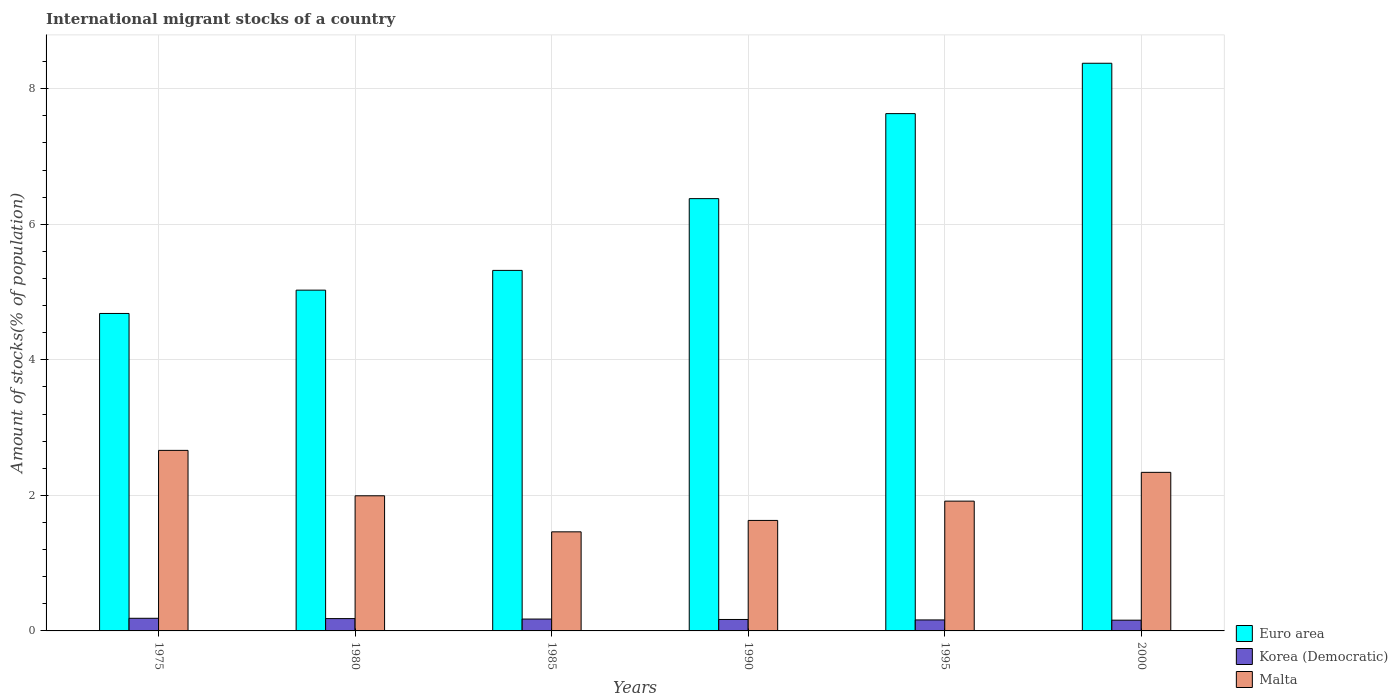How many different coloured bars are there?
Provide a short and direct response. 3. How many groups of bars are there?
Your response must be concise. 6. How many bars are there on the 5th tick from the left?
Keep it short and to the point. 3. What is the label of the 2nd group of bars from the left?
Make the answer very short. 1980. What is the amount of stocks in in Korea (Democratic) in 2000?
Offer a terse response. 0.16. Across all years, what is the maximum amount of stocks in in Euro area?
Your answer should be compact. 8.38. Across all years, what is the minimum amount of stocks in in Euro area?
Provide a short and direct response. 4.68. In which year was the amount of stocks in in Euro area minimum?
Ensure brevity in your answer.  1975. What is the total amount of stocks in in Korea (Democratic) in the graph?
Make the answer very short. 1.03. What is the difference between the amount of stocks in in Korea (Democratic) in 1975 and that in 1995?
Give a very brief answer. 0.02. What is the difference between the amount of stocks in in Korea (Democratic) in 1995 and the amount of stocks in in Malta in 1990?
Make the answer very short. -1.47. What is the average amount of stocks in in Malta per year?
Your answer should be compact. 2. In the year 1980, what is the difference between the amount of stocks in in Malta and amount of stocks in in Korea (Democratic)?
Your answer should be compact. 1.81. In how many years, is the amount of stocks in in Malta greater than 4.8 %?
Your response must be concise. 0. What is the ratio of the amount of stocks in in Malta in 1975 to that in 1980?
Ensure brevity in your answer.  1.34. What is the difference between the highest and the second highest amount of stocks in in Euro area?
Your answer should be compact. 0.74. What is the difference between the highest and the lowest amount of stocks in in Korea (Democratic)?
Provide a succinct answer. 0.03. In how many years, is the amount of stocks in in Malta greater than the average amount of stocks in in Malta taken over all years?
Offer a terse response. 2. What does the 3rd bar from the left in 1995 represents?
Provide a short and direct response. Malta. What does the 1st bar from the right in 1985 represents?
Offer a terse response. Malta. Does the graph contain any zero values?
Give a very brief answer. No. Does the graph contain grids?
Your response must be concise. Yes. Where does the legend appear in the graph?
Keep it short and to the point. Bottom right. How are the legend labels stacked?
Offer a very short reply. Vertical. What is the title of the graph?
Make the answer very short. International migrant stocks of a country. Does "Philippines" appear as one of the legend labels in the graph?
Offer a terse response. No. What is the label or title of the Y-axis?
Offer a very short reply. Amount of stocks(% of population). What is the Amount of stocks(% of population) in Euro area in 1975?
Offer a very short reply. 4.68. What is the Amount of stocks(% of population) in Korea (Democratic) in 1975?
Your answer should be compact. 0.19. What is the Amount of stocks(% of population) of Malta in 1975?
Your answer should be very brief. 2.66. What is the Amount of stocks(% of population) in Euro area in 1980?
Offer a terse response. 5.03. What is the Amount of stocks(% of population) in Korea (Democratic) in 1980?
Make the answer very short. 0.18. What is the Amount of stocks(% of population) in Malta in 1980?
Provide a short and direct response. 1.99. What is the Amount of stocks(% of population) in Euro area in 1985?
Provide a short and direct response. 5.32. What is the Amount of stocks(% of population) in Korea (Democratic) in 1985?
Give a very brief answer. 0.17. What is the Amount of stocks(% of population) of Malta in 1985?
Your response must be concise. 1.46. What is the Amount of stocks(% of population) in Euro area in 1990?
Your answer should be compact. 6.38. What is the Amount of stocks(% of population) of Korea (Democratic) in 1990?
Offer a terse response. 0.17. What is the Amount of stocks(% of population) in Malta in 1990?
Give a very brief answer. 1.63. What is the Amount of stocks(% of population) of Euro area in 1995?
Your answer should be compact. 7.63. What is the Amount of stocks(% of population) in Korea (Democratic) in 1995?
Make the answer very short. 0.16. What is the Amount of stocks(% of population) in Malta in 1995?
Offer a very short reply. 1.92. What is the Amount of stocks(% of population) in Euro area in 2000?
Offer a very short reply. 8.38. What is the Amount of stocks(% of population) of Korea (Democratic) in 2000?
Your response must be concise. 0.16. What is the Amount of stocks(% of population) in Malta in 2000?
Provide a short and direct response. 2.34. Across all years, what is the maximum Amount of stocks(% of population) in Euro area?
Offer a terse response. 8.38. Across all years, what is the maximum Amount of stocks(% of population) of Korea (Democratic)?
Your response must be concise. 0.19. Across all years, what is the maximum Amount of stocks(% of population) in Malta?
Make the answer very short. 2.66. Across all years, what is the minimum Amount of stocks(% of population) in Euro area?
Your response must be concise. 4.68. Across all years, what is the minimum Amount of stocks(% of population) in Korea (Democratic)?
Provide a short and direct response. 0.16. Across all years, what is the minimum Amount of stocks(% of population) in Malta?
Your answer should be compact. 1.46. What is the total Amount of stocks(% of population) in Euro area in the graph?
Your response must be concise. 37.42. What is the total Amount of stocks(% of population) of Korea (Democratic) in the graph?
Give a very brief answer. 1.03. What is the total Amount of stocks(% of population) of Malta in the graph?
Ensure brevity in your answer.  12. What is the difference between the Amount of stocks(% of population) in Euro area in 1975 and that in 1980?
Your answer should be very brief. -0.34. What is the difference between the Amount of stocks(% of population) of Korea (Democratic) in 1975 and that in 1980?
Offer a terse response. 0. What is the difference between the Amount of stocks(% of population) in Malta in 1975 and that in 1980?
Ensure brevity in your answer.  0.67. What is the difference between the Amount of stocks(% of population) of Euro area in 1975 and that in 1985?
Make the answer very short. -0.64. What is the difference between the Amount of stocks(% of population) of Korea (Democratic) in 1975 and that in 1985?
Keep it short and to the point. 0.01. What is the difference between the Amount of stocks(% of population) of Malta in 1975 and that in 1985?
Provide a succinct answer. 1.2. What is the difference between the Amount of stocks(% of population) in Euro area in 1975 and that in 1990?
Provide a short and direct response. -1.69. What is the difference between the Amount of stocks(% of population) of Korea (Democratic) in 1975 and that in 1990?
Make the answer very short. 0.02. What is the difference between the Amount of stocks(% of population) of Malta in 1975 and that in 1990?
Offer a terse response. 1.03. What is the difference between the Amount of stocks(% of population) in Euro area in 1975 and that in 1995?
Give a very brief answer. -2.95. What is the difference between the Amount of stocks(% of population) of Korea (Democratic) in 1975 and that in 1995?
Ensure brevity in your answer.  0.02. What is the difference between the Amount of stocks(% of population) in Malta in 1975 and that in 1995?
Your answer should be compact. 0.75. What is the difference between the Amount of stocks(% of population) in Euro area in 1975 and that in 2000?
Provide a short and direct response. -3.69. What is the difference between the Amount of stocks(% of population) of Korea (Democratic) in 1975 and that in 2000?
Your answer should be compact. 0.03. What is the difference between the Amount of stocks(% of population) in Malta in 1975 and that in 2000?
Your response must be concise. 0.32. What is the difference between the Amount of stocks(% of population) of Euro area in 1980 and that in 1985?
Your response must be concise. -0.29. What is the difference between the Amount of stocks(% of population) in Korea (Democratic) in 1980 and that in 1985?
Offer a terse response. 0.01. What is the difference between the Amount of stocks(% of population) of Malta in 1980 and that in 1985?
Your answer should be compact. 0.53. What is the difference between the Amount of stocks(% of population) of Euro area in 1980 and that in 1990?
Provide a succinct answer. -1.35. What is the difference between the Amount of stocks(% of population) in Korea (Democratic) in 1980 and that in 1990?
Your answer should be compact. 0.01. What is the difference between the Amount of stocks(% of population) of Malta in 1980 and that in 1990?
Your response must be concise. 0.36. What is the difference between the Amount of stocks(% of population) in Euro area in 1980 and that in 1995?
Offer a terse response. -2.6. What is the difference between the Amount of stocks(% of population) of Korea (Democratic) in 1980 and that in 1995?
Make the answer very short. 0.02. What is the difference between the Amount of stocks(% of population) of Malta in 1980 and that in 1995?
Offer a very short reply. 0.08. What is the difference between the Amount of stocks(% of population) of Euro area in 1980 and that in 2000?
Provide a short and direct response. -3.35. What is the difference between the Amount of stocks(% of population) in Korea (Democratic) in 1980 and that in 2000?
Your answer should be very brief. 0.02. What is the difference between the Amount of stocks(% of population) of Malta in 1980 and that in 2000?
Keep it short and to the point. -0.35. What is the difference between the Amount of stocks(% of population) in Euro area in 1985 and that in 1990?
Your answer should be compact. -1.06. What is the difference between the Amount of stocks(% of population) in Korea (Democratic) in 1985 and that in 1990?
Offer a very short reply. 0.01. What is the difference between the Amount of stocks(% of population) in Malta in 1985 and that in 1990?
Your answer should be compact. -0.17. What is the difference between the Amount of stocks(% of population) of Euro area in 1985 and that in 1995?
Offer a terse response. -2.31. What is the difference between the Amount of stocks(% of population) of Korea (Democratic) in 1985 and that in 1995?
Make the answer very short. 0.01. What is the difference between the Amount of stocks(% of population) in Malta in 1985 and that in 1995?
Your answer should be compact. -0.45. What is the difference between the Amount of stocks(% of population) of Euro area in 1985 and that in 2000?
Provide a succinct answer. -3.06. What is the difference between the Amount of stocks(% of population) of Korea (Democratic) in 1985 and that in 2000?
Provide a succinct answer. 0.02. What is the difference between the Amount of stocks(% of population) in Malta in 1985 and that in 2000?
Provide a short and direct response. -0.88. What is the difference between the Amount of stocks(% of population) in Euro area in 1990 and that in 1995?
Provide a succinct answer. -1.25. What is the difference between the Amount of stocks(% of population) of Korea (Democratic) in 1990 and that in 1995?
Keep it short and to the point. 0.01. What is the difference between the Amount of stocks(% of population) of Malta in 1990 and that in 1995?
Provide a short and direct response. -0.28. What is the difference between the Amount of stocks(% of population) of Euro area in 1990 and that in 2000?
Provide a short and direct response. -2. What is the difference between the Amount of stocks(% of population) in Korea (Democratic) in 1990 and that in 2000?
Ensure brevity in your answer.  0.01. What is the difference between the Amount of stocks(% of population) of Malta in 1990 and that in 2000?
Ensure brevity in your answer.  -0.71. What is the difference between the Amount of stocks(% of population) in Euro area in 1995 and that in 2000?
Provide a short and direct response. -0.74. What is the difference between the Amount of stocks(% of population) in Korea (Democratic) in 1995 and that in 2000?
Ensure brevity in your answer.  0. What is the difference between the Amount of stocks(% of population) in Malta in 1995 and that in 2000?
Provide a short and direct response. -0.42. What is the difference between the Amount of stocks(% of population) in Euro area in 1975 and the Amount of stocks(% of population) in Korea (Democratic) in 1980?
Keep it short and to the point. 4.5. What is the difference between the Amount of stocks(% of population) in Euro area in 1975 and the Amount of stocks(% of population) in Malta in 1980?
Keep it short and to the point. 2.69. What is the difference between the Amount of stocks(% of population) in Korea (Democratic) in 1975 and the Amount of stocks(% of population) in Malta in 1980?
Offer a very short reply. -1.81. What is the difference between the Amount of stocks(% of population) in Euro area in 1975 and the Amount of stocks(% of population) in Korea (Democratic) in 1985?
Your response must be concise. 4.51. What is the difference between the Amount of stocks(% of population) of Euro area in 1975 and the Amount of stocks(% of population) of Malta in 1985?
Make the answer very short. 3.22. What is the difference between the Amount of stocks(% of population) in Korea (Democratic) in 1975 and the Amount of stocks(% of population) in Malta in 1985?
Keep it short and to the point. -1.28. What is the difference between the Amount of stocks(% of population) in Euro area in 1975 and the Amount of stocks(% of population) in Korea (Democratic) in 1990?
Keep it short and to the point. 4.52. What is the difference between the Amount of stocks(% of population) of Euro area in 1975 and the Amount of stocks(% of population) of Malta in 1990?
Provide a succinct answer. 3.05. What is the difference between the Amount of stocks(% of population) in Korea (Democratic) in 1975 and the Amount of stocks(% of population) in Malta in 1990?
Offer a very short reply. -1.44. What is the difference between the Amount of stocks(% of population) of Euro area in 1975 and the Amount of stocks(% of population) of Korea (Democratic) in 1995?
Offer a very short reply. 4.52. What is the difference between the Amount of stocks(% of population) in Euro area in 1975 and the Amount of stocks(% of population) in Malta in 1995?
Your response must be concise. 2.77. What is the difference between the Amount of stocks(% of population) of Korea (Democratic) in 1975 and the Amount of stocks(% of population) of Malta in 1995?
Offer a very short reply. -1.73. What is the difference between the Amount of stocks(% of population) in Euro area in 1975 and the Amount of stocks(% of population) in Korea (Democratic) in 2000?
Offer a very short reply. 4.53. What is the difference between the Amount of stocks(% of population) in Euro area in 1975 and the Amount of stocks(% of population) in Malta in 2000?
Your answer should be compact. 2.34. What is the difference between the Amount of stocks(% of population) of Korea (Democratic) in 1975 and the Amount of stocks(% of population) of Malta in 2000?
Your answer should be very brief. -2.15. What is the difference between the Amount of stocks(% of population) of Euro area in 1980 and the Amount of stocks(% of population) of Korea (Democratic) in 1985?
Keep it short and to the point. 4.85. What is the difference between the Amount of stocks(% of population) in Euro area in 1980 and the Amount of stocks(% of population) in Malta in 1985?
Offer a very short reply. 3.57. What is the difference between the Amount of stocks(% of population) of Korea (Democratic) in 1980 and the Amount of stocks(% of population) of Malta in 1985?
Your answer should be compact. -1.28. What is the difference between the Amount of stocks(% of population) of Euro area in 1980 and the Amount of stocks(% of population) of Korea (Democratic) in 1990?
Your answer should be compact. 4.86. What is the difference between the Amount of stocks(% of population) in Euro area in 1980 and the Amount of stocks(% of population) in Malta in 1990?
Your answer should be very brief. 3.4. What is the difference between the Amount of stocks(% of population) in Korea (Democratic) in 1980 and the Amount of stocks(% of population) in Malta in 1990?
Offer a terse response. -1.45. What is the difference between the Amount of stocks(% of population) of Euro area in 1980 and the Amount of stocks(% of population) of Korea (Democratic) in 1995?
Make the answer very short. 4.87. What is the difference between the Amount of stocks(% of population) of Euro area in 1980 and the Amount of stocks(% of population) of Malta in 1995?
Ensure brevity in your answer.  3.11. What is the difference between the Amount of stocks(% of population) in Korea (Democratic) in 1980 and the Amount of stocks(% of population) in Malta in 1995?
Keep it short and to the point. -1.73. What is the difference between the Amount of stocks(% of population) in Euro area in 1980 and the Amount of stocks(% of population) in Korea (Democratic) in 2000?
Give a very brief answer. 4.87. What is the difference between the Amount of stocks(% of population) of Euro area in 1980 and the Amount of stocks(% of population) of Malta in 2000?
Keep it short and to the point. 2.69. What is the difference between the Amount of stocks(% of population) in Korea (Democratic) in 1980 and the Amount of stocks(% of population) in Malta in 2000?
Your answer should be compact. -2.16. What is the difference between the Amount of stocks(% of population) of Euro area in 1985 and the Amount of stocks(% of population) of Korea (Democratic) in 1990?
Offer a very short reply. 5.15. What is the difference between the Amount of stocks(% of population) of Euro area in 1985 and the Amount of stocks(% of population) of Malta in 1990?
Offer a very short reply. 3.69. What is the difference between the Amount of stocks(% of population) in Korea (Democratic) in 1985 and the Amount of stocks(% of population) in Malta in 1990?
Offer a very short reply. -1.46. What is the difference between the Amount of stocks(% of population) of Euro area in 1985 and the Amount of stocks(% of population) of Korea (Democratic) in 1995?
Give a very brief answer. 5.16. What is the difference between the Amount of stocks(% of population) of Euro area in 1985 and the Amount of stocks(% of population) of Malta in 1995?
Offer a very short reply. 3.4. What is the difference between the Amount of stocks(% of population) in Korea (Democratic) in 1985 and the Amount of stocks(% of population) in Malta in 1995?
Make the answer very short. -1.74. What is the difference between the Amount of stocks(% of population) in Euro area in 1985 and the Amount of stocks(% of population) in Korea (Democratic) in 2000?
Keep it short and to the point. 5.16. What is the difference between the Amount of stocks(% of population) in Euro area in 1985 and the Amount of stocks(% of population) in Malta in 2000?
Offer a very short reply. 2.98. What is the difference between the Amount of stocks(% of population) of Korea (Democratic) in 1985 and the Amount of stocks(% of population) of Malta in 2000?
Your answer should be compact. -2.16. What is the difference between the Amount of stocks(% of population) in Euro area in 1990 and the Amount of stocks(% of population) in Korea (Democratic) in 1995?
Keep it short and to the point. 6.22. What is the difference between the Amount of stocks(% of population) of Euro area in 1990 and the Amount of stocks(% of population) of Malta in 1995?
Offer a terse response. 4.46. What is the difference between the Amount of stocks(% of population) of Korea (Democratic) in 1990 and the Amount of stocks(% of population) of Malta in 1995?
Your answer should be very brief. -1.75. What is the difference between the Amount of stocks(% of population) of Euro area in 1990 and the Amount of stocks(% of population) of Korea (Democratic) in 2000?
Your answer should be very brief. 6.22. What is the difference between the Amount of stocks(% of population) in Euro area in 1990 and the Amount of stocks(% of population) in Malta in 2000?
Ensure brevity in your answer.  4.04. What is the difference between the Amount of stocks(% of population) in Korea (Democratic) in 1990 and the Amount of stocks(% of population) in Malta in 2000?
Your answer should be very brief. -2.17. What is the difference between the Amount of stocks(% of population) of Euro area in 1995 and the Amount of stocks(% of population) of Korea (Democratic) in 2000?
Your answer should be compact. 7.47. What is the difference between the Amount of stocks(% of population) of Euro area in 1995 and the Amount of stocks(% of population) of Malta in 2000?
Offer a terse response. 5.29. What is the difference between the Amount of stocks(% of population) of Korea (Democratic) in 1995 and the Amount of stocks(% of population) of Malta in 2000?
Offer a very short reply. -2.18. What is the average Amount of stocks(% of population) of Euro area per year?
Your answer should be compact. 6.24. What is the average Amount of stocks(% of population) in Korea (Democratic) per year?
Your answer should be very brief. 0.17. What is the average Amount of stocks(% of population) in Malta per year?
Make the answer very short. 2. In the year 1975, what is the difference between the Amount of stocks(% of population) in Euro area and Amount of stocks(% of population) in Korea (Democratic)?
Your answer should be very brief. 4.5. In the year 1975, what is the difference between the Amount of stocks(% of population) in Euro area and Amount of stocks(% of population) in Malta?
Offer a terse response. 2.02. In the year 1975, what is the difference between the Amount of stocks(% of population) of Korea (Democratic) and Amount of stocks(% of population) of Malta?
Provide a short and direct response. -2.48. In the year 1980, what is the difference between the Amount of stocks(% of population) in Euro area and Amount of stocks(% of population) in Korea (Democratic)?
Provide a short and direct response. 4.85. In the year 1980, what is the difference between the Amount of stocks(% of population) in Euro area and Amount of stocks(% of population) in Malta?
Keep it short and to the point. 3.03. In the year 1980, what is the difference between the Amount of stocks(% of population) in Korea (Democratic) and Amount of stocks(% of population) in Malta?
Your answer should be very brief. -1.81. In the year 1985, what is the difference between the Amount of stocks(% of population) of Euro area and Amount of stocks(% of population) of Korea (Democratic)?
Make the answer very short. 5.14. In the year 1985, what is the difference between the Amount of stocks(% of population) of Euro area and Amount of stocks(% of population) of Malta?
Make the answer very short. 3.86. In the year 1985, what is the difference between the Amount of stocks(% of population) of Korea (Democratic) and Amount of stocks(% of population) of Malta?
Your answer should be very brief. -1.29. In the year 1990, what is the difference between the Amount of stocks(% of population) of Euro area and Amount of stocks(% of population) of Korea (Democratic)?
Offer a terse response. 6.21. In the year 1990, what is the difference between the Amount of stocks(% of population) in Euro area and Amount of stocks(% of population) in Malta?
Your answer should be compact. 4.75. In the year 1990, what is the difference between the Amount of stocks(% of population) in Korea (Democratic) and Amount of stocks(% of population) in Malta?
Make the answer very short. -1.46. In the year 1995, what is the difference between the Amount of stocks(% of population) in Euro area and Amount of stocks(% of population) in Korea (Democratic)?
Provide a short and direct response. 7.47. In the year 1995, what is the difference between the Amount of stocks(% of population) of Euro area and Amount of stocks(% of population) of Malta?
Ensure brevity in your answer.  5.72. In the year 1995, what is the difference between the Amount of stocks(% of population) of Korea (Democratic) and Amount of stocks(% of population) of Malta?
Keep it short and to the point. -1.75. In the year 2000, what is the difference between the Amount of stocks(% of population) in Euro area and Amount of stocks(% of population) in Korea (Democratic)?
Provide a succinct answer. 8.22. In the year 2000, what is the difference between the Amount of stocks(% of population) in Euro area and Amount of stocks(% of population) in Malta?
Ensure brevity in your answer.  6.04. In the year 2000, what is the difference between the Amount of stocks(% of population) of Korea (Democratic) and Amount of stocks(% of population) of Malta?
Keep it short and to the point. -2.18. What is the ratio of the Amount of stocks(% of population) in Euro area in 1975 to that in 1980?
Ensure brevity in your answer.  0.93. What is the ratio of the Amount of stocks(% of population) of Korea (Democratic) in 1975 to that in 1980?
Provide a short and direct response. 1.03. What is the ratio of the Amount of stocks(% of population) in Malta in 1975 to that in 1980?
Provide a succinct answer. 1.34. What is the ratio of the Amount of stocks(% of population) in Euro area in 1975 to that in 1985?
Provide a succinct answer. 0.88. What is the ratio of the Amount of stocks(% of population) of Korea (Democratic) in 1975 to that in 1985?
Ensure brevity in your answer.  1.07. What is the ratio of the Amount of stocks(% of population) of Malta in 1975 to that in 1985?
Your answer should be compact. 1.82. What is the ratio of the Amount of stocks(% of population) in Euro area in 1975 to that in 1990?
Make the answer very short. 0.73. What is the ratio of the Amount of stocks(% of population) of Korea (Democratic) in 1975 to that in 1990?
Provide a succinct answer. 1.1. What is the ratio of the Amount of stocks(% of population) of Malta in 1975 to that in 1990?
Your answer should be compact. 1.63. What is the ratio of the Amount of stocks(% of population) of Euro area in 1975 to that in 1995?
Keep it short and to the point. 0.61. What is the ratio of the Amount of stocks(% of population) in Korea (Democratic) in 1975 to that in 1995?
Offer a very short reply. 1.15. What is the ratio of the Amount of stocks(% of population) in Malta in 1975 to that in 1995?
Give a very brief answer. 1.39. What is the ratio of the Amount of stocks(% of population) of Euro area in 1975 to that in 2000?
Make the answer very short. 0.56. What is the ratio of the Amount of stocks(% of population) in Korea (Democratic) in 1975 to that in 2000?
Offer a terse response. 1.18. What is the ratio of the Amount of stocks(% of population) in Malta in 1975 to that in 2000?
Provide a succinct answer. 1.14. What is the ratio of the Amount of stocks(% of population) in Euro area in 1980 to that in 1985?
Give a very brief answer. 0.95. What is the ratio of the Amount of stocks(% of population) in Korea (Democratic) in 1980 to that in 1985?
Give a very brief answer. 1.04. What is the ratio of the Amount of stocks(% of population) of Malta in 1980 to that in 1985?
Provide a short and direct response. 1.36. What is the ratio of the Amount of stocks(% of population) of Euro area in 1980 to that in 1990?
Provide a succinct answer. 0.79. What is the ratio of the Amount of stocks(% of population) of Korea (Democratic) in 1980 to that in 1990?
Offer a terse response. 1.08. What is the ratio of the Amount of stocks(% of population) in Malta in 1980 to that in 1990?
Your answer should be compact. 1.22. What is the ratio of the Amount of stocks(% of population) of Euro area in 1980 to that in 1995?
Keep it short and to the point. 0.66. What is the ratio of the Amount of stocks(% of population) in Korea (Democratic) in 1980 to that in 1995?
Your answer should be compact. 1.12. What is the ratio of the Amount of stocks(% of population) in Malta in 1980 to that in 1995?
Offer a very short reply. 1.04. What is the ratio of the Amount of stocks(% of population) of Euro area in 1980 to that in 2000?
Ensure brevity in your answer.  0.6. What is the ratio of the Amount of stocks(% of population) in Korea (Democratic) in 1980 to that in 2000?
Provide a short and direct response. 1.15. What is the ratio of the Amount of stocks(% of population) of Malta in 1980 to that in 2000?
Make the answer very short. 0.85. What is the ratio of the Amount of stocks(% of population) in Euro area in 1985 to that in 1990?
Keep it short and to the point. 0.83. What is the ratio of the Amount of stocks(% of population) in Korea (Democratic) in 1985 to that in 1990?
Provide a succinct answer. 1.04. What is the ratio of the Amount of stocks(% of population) of Malta in 1985 to that in 1990?
Offer a terse response. 0.9. What is the ratio of the Amount of stocks(% of population) in Euro area in 1985 to that in 1995?
Your response must be concise. 0.7. What is the ratio of the Amount of stocks(% of population) of Korea (Democratic) in 1985 to that in 1995?
Provide a short and direct response. 1.08. What is the ratio of the Amount of stocks(% of population) of Malta in 1985 to that in 1995?
Provide a short and direct response. 0.76. What is the ratio of the Amount of stocks(% of population) in Euro area in 1985 to that in 2000?
Offer a very short reply. 0.64. What is the ratio of the Amount of stocks(% of population) of Korea (Democratic) in 1985 to that in 2000?
Provide a short and direct response. 1.1. What is the ratio of the Amount of stocks(% of population) of Malta in 1985 to that in 2000?
Your response must be concise. 0.62. What is the ratio of the Amount of stocks(% of population) in Euro area in 1990 to that in 1995?
Ensure brevity in your answer.  0.84. What is the ratio of the Amount of stocks(% of population) of Korea (Democratic) in 1990 to that in 1995?
Make the answer very short. 1.04. What is the ratio of the Amount of stocks(% of population) of Malta in 1990 to that in 1995?
Ensure brevity in your answer.  0.85. What is the ratio of the Amount of stocks(% of population) in Euro area in 1990 to that in 2000?
Offer a very short reply. 0.76. What is the ratio of the Amount of stocks(% of population) in Korea (Democratic) in 1990 to that in 2000?
Your response must be concise. 1.07. What is the ratio of the Amount of stocks(% of population) of Malta in 1990 to that in 2000?
Provide a short and direct response. 0.7. What is the ratio of the Amount of stocks(% of population) of Euro area in 1995 to that in 2000?
Offer a very short reply. 0.91. What is the ratio of the Amount of stocks(% of population) in Korea (Democratic) in 1995 to that in 2000?
Provide a short and direct response. 1.02. What is the ratio of the Amount of stocks(% of population) of Malta in 1995 to that in 2000?
Offer a very short reply. 0.82. What is the difference between the highest and the second highest Amount of stocks(% of population) of Euro area?
Provide a succinct answer. 0.74. What is the difference between the highest and the second highest Amount of stocks(% of population) of Korea (Democratic)?
Give a very brief answer. 0. What is the difference between the highest and the second highest Amount of stocks(% of population) of Malta?
Your answer should be very brief. 0.32. What is the difference between the highest and the lowest Amount of stocks(% of population) in Euro area?
Your answer should be very brief. 3.69. What is the difference between the highest and the lowest Amount of stocks(% of population) of Korea (Democratic)?
Provide a short and direct response. 0.03. What is the difference between the highest and the lowest Amount of stocks(% of population) in Malta?
Your answer should be very brief. 1.2. 